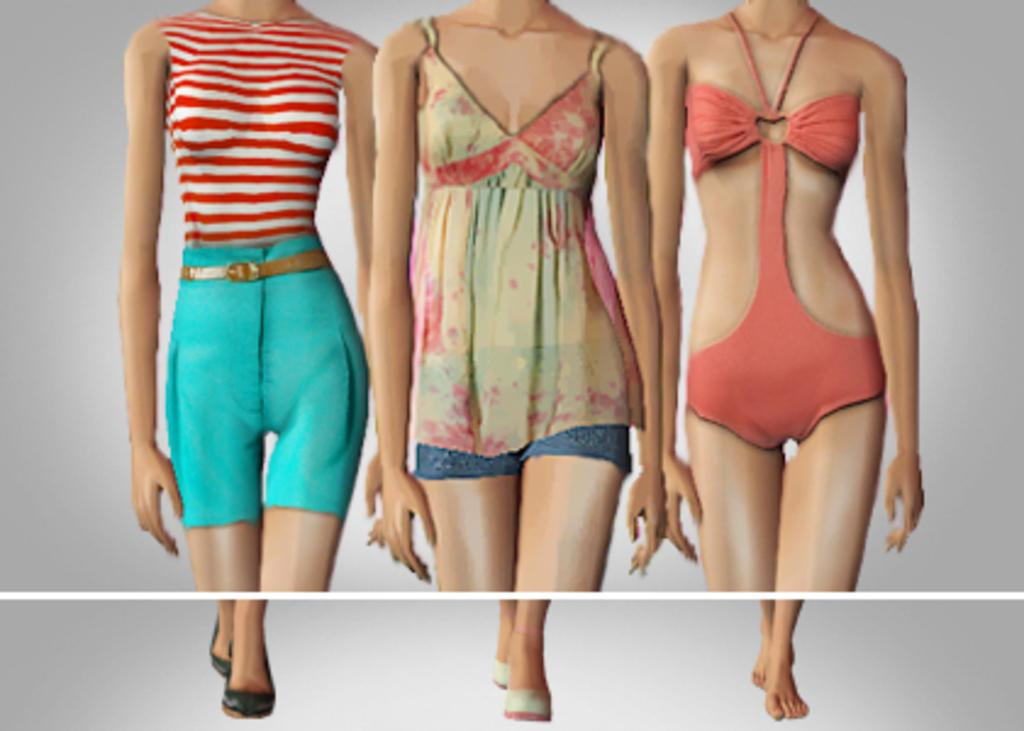What type of image is being described? The image is an animated picture. How many bodies are present in the image? There are three bodies in the image. What part of the bodies can be seen in the image? Legs are visible in the image. What time of day is depicted in the image? The provided facts do not mention the time of day, so it cannot be determined from the image. 